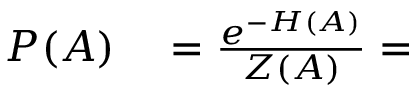Convert formula to latex. <formula><loc_0><loc_0><loc_500><loc_500>\begin{array} { r l } { P ( A ) } & = \frac { e ^ { - H ( A ) } } { Z ( A ) } = } \end{array}</formula> 